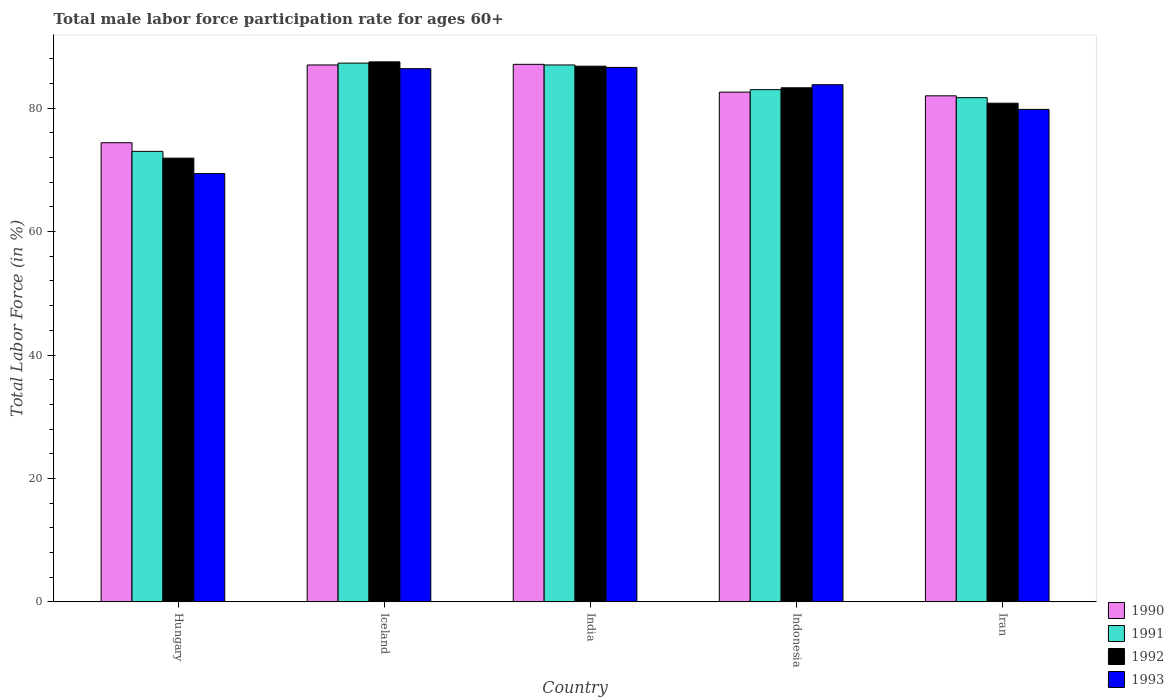How many different coloured bars are there?
Your response must be concise. 4. How many groups of bars are there?
Keep it short and to the point. 5. Are the number of bars per tick equal to the number of legend labels?
Give a very brief answer. Yes. Are the number of bars on each tick of the X-axis equal?
Offer a very short reply. Yes. How many bars are there on the 5th tick from the left?
Your response must be concise. 4. How many bars are there on the 5th tick from the right?
Keep it short and to the point. 4. What is the male labor force participation rate in 1992 in Iran?
Offer a terse response. 80.8. Across all countries, what is the maximum male labor force participation rate in 1990?
Keep it short and to the point. 87.1. Across all countries, what is the minimum male labor force participation rate in 1990?
Your answer should be compact. 74.4. In which country was the male labor force participation rate in 1991 maximum?
Give a very brief answer. Iceland. In which country was the male labor force participation rate in 1992 minimum?
Your answer should be compact. Hungary. What is the total male labor force participation rate in 1990 in the graph?
Offer a terse response. 413.1. What is the difference between the male labor force participation rate in 1992 in Hungary and that in India?
Your response must be concise. -14.9. What is the average male labor force participation rate in 1992 per country?
Offer a terse response. 82.06. In how many countries, is the male labor force participation rate in 1991 greater than 64 %?
Give a very brief answer. 5. What is the ratio of the male labor force participation rate in 1992 in Iceland to that in Iran?
Your answer should be compact. 1.08. What is the difference between the highest and the second highest male labor force participation rate in 1992?
Ensure brevity in your answer.  -3.5. What is the difference between the highest and the lowest male labor force participation rate in 1992?
Your response must be concise. 15.6. In how many countries, is the male labor force participation rate in 1990 greater than the average male labor force participation rate in 1990 taken over all countries?
Make the answer very short. 2. Is it the case that in every country, the sum of the male labor force participation rate in 1991 and male labor force participation rate in 1993 is greater than the sum of male labor force participation rate in 1990 and male labor force participation rate in 1992?
Ensure brevity in your answer.  No. What does the 1st bar from the right in Indonesia represents?
Keep it short and to the point. 1993. Is it the case that in every country, the sum of the male labor force participation rate in 1993 and male labor force participation rate in 1990 is greater than the male labor force participation rate in 1992?
Your answer should be compact. Yes. Are all the bars in the graph horizontal?
Offer a very short reply. No. How many countries are there in the graph?
Your response must be concise. 5. Are the values on the major ticks of Y-axis written in scientific E-notation?
Offer a terse response. No. Does the graph contain grids?
Give a very brief answer. No. Where does the legend appear in the graph?
Provide a succinct answer. Bottom right. How many legend labels are there?
Your response must be concise. 4. What is the title of the graph?
Give a very brief answer. Total male labor force participation rate for ages 60+. What is the label or title of the X-axis?
Offer a very short reply. Country. What is the label or title of the Y-axis?
Provide a succinct answer. Total Labor Force (in %). What is the Total Labor Force (in %) of 1990 in Hungary?
Your response must be concise. 74.4. What is the Total Labor Force (in %) of 1991 in Hungary?
Your answer should be compact. 73. What is the Total Labor Force (in %) in 1992 in Hungary?
Ensure brevity in your answer.  71.9. What is the Total Labor Force (in %) of 1993 in Hungary?
Keep it short and to the point. 69.4. What is the Total Labor Force (in %) in 1991 in Iceland?
Your response must be concise. 87.3. What is the Total Labor Force (in %) of 1992 in Iceland?
Your answer should be compact. 87.5. What is the Total Labor Force (in %) in 1993 in Iceland?
Keep it short and to the point. 86.4. What is the Total Labor Force (in %) of 1990 in India?
Keep it short and to the point. 87.1. What is the Total Labor Force (in %) of 1992 in India?
Your response must be concise. 86.8. What is the Total Labor Force (in %) of 1993 in India?
Your answer should be compact. 86.6. What is the Total Labor Force (in %) in 1990 in Indonesia?
Provide a succinct answer. 82.6. What is the Total Labor Force (in %) in 1991 in Indonesia?
Give a very brief answer. 83. What is the Total Labor Force (in %) of 1992 in Indonesia?
Your answer should be very brief. 83.3. What is the Total Labor Force (in %) of 1993 in Indonesia?
Provide a short and direct response. 83.8. What is the Total Labor Force (in %) in 1990 in Iran?
Provide a short and direct response. 82. What is the Total Labor Force (in %) in 1991 in Iran?
Offer a very short reply. 81.7. What is the Total Labor Force (in %) in 1992 in Iran?
Give a very brief answer. 80.8. What is the Total Labor Force (in %) of 1993 in Iran?
Give a very brief answer. 79.8. Across all countries, what is the maximum Total Labor Force (in %) of 1990?
Provide a short and direct response. 87.1. Across all countries, what is the maximum Total Labor Force (in %) in 1991?
Offer a very short reply. 87.3. Across all countries, what is the maximum Total Labor Force (in %) in 1992?
Keep it short and to the point. 87.5. Across all countries, what is the maximum Total Labor Force (in %) in 1993?
Offer a terse response. 86.6. Across all countries, what is the minimum Total Labor Force (in %) in 1990?
Provide a succinct answer. 74.4. Across all countries, what is the minimum Total Labor Force (in %) in 1992?
Ensure brevity in your answer.  71.9. Across all countries, what is the minimum Total Labor Force (in %) of 1993?
Ensure brevity in your answer.  69.4. What is the total Total Labor Force (in %) in 1990 in the graph?
Make the answer very short. 413.1. What is the total Total Labor Force (in %) in 1991 in the graph?
Provide a short and direct response. 412. What is the total Total Labor Force (in %) of 1992 in the graph?
Your answer should be very brief. 410.3. What is the total Total Labor Force (in %) in 1993 in the graph?
Give a very brief answer. 406. What is the difference between the Total Labor Force (in %) of 1990 in Hungary and that in Iceland?
Ensure brevity in your answer.  -12.6. What is the difference between the Total Labor Force (in %) in 1991 in Hungary and that in Iceland?
Offer a very short reply. -14.3. What is the difference between the Total Labor Force (in %) of 1992 in Hungary and that in Iceland?
Provide a succinct answer. -15.6. What is the difference between the Total Labor Force (in %) of 1993 in Hungary and that in Iceland?
Give a very brief answer. -17. What is the difference between the Total Labor Force (in %) in 1990 in Hungary and that in India?
Ensure brevity in your answer.  -12.7. What is the difference between the Total Labor Force (in %) in 1992 in Hungary and that in India?
Your response must be concise. -14.9. What is the difference between the Total Labor Force (in %) in 1993 in Hungary and that in India?
Make the answer very short. -17.2. What is the difference between the Total Labor Force (in %) of 1990 in Hungary and that in Indonesia?
Offer a terse response. -8.2. What is the difference between the Total Labor Force (in %) of 1993 in Hungary and that in Indonesia?
Provide a succinct answer. -14.4. What is the difference between the Total Labor Force (in %) in 1990 in Hungary and that in Iran?
Provide a short and direct response. -7.6. What is the difference between the Total Labor Force (in %) of 1991 in Hungary and that in Iran?
Offer a terse response. -8.7. What is the difference between the Total Labor Force (in %) in 1993 in Hungary and that in Iran?
Keep it short and to the point. -10.4. What is the difference between the Total Labor Force (in %) of 1990 in Iceland and that in India?
Your answer should be compact. -0.1. What is the difference between the Total Labor Force (in %) in 1990 in Iceland and that in Indonesia?
Ensure brevity in your answer.  4.4. What is the difference between the Total Labor Force (in %) of 1992 in Iceland and that in Indonesia?
Your answer should be very brief. 4.2. What is the difference between the Total Labor Force (in %) in 1993 in Iceland and that in Indonesia?
Give a very brief answer. 2.6. What is the difference between the Total Labor Force (in %) of 1992 in Iceland and that in Iran?
Provide a short and direct response. 6.7. What is the difference between the Total Labor Force (in %) of 1990 in India and that in Indonesia?
Offer a very short reply. 4.5. What is the difference between the Total Labor Force (in %) of 1992 in India and that in Indonesia?
Your answer should be compact. 3.5. What is the difference between the Total Labor Force (in %) of 1993 in India and that in Indonesia?
Keep it short and to the point. 2.8. What is the difference between the Total Labor Force (in %) of 1990 in India and that in Iran?
Ensure brevity in your answer.  5.1. What is the difference between the Total Labor Force (in %) of 1991 in India and that in Iran?
Your response must be concise. 5.3. What is the difference between the Total Labor Force (in %) of 1993 in India and that in Iran?
Offer a very short reply. 6.8. What is the difference between the Total Labor Force (in %) of 1991 in Indonesia and that in Iran?
Provide a succinct answer. 1.3. What is the difference between the Total Labor Force (in %) of 1992 in Indonesia and that in Iran?
Provide a succinct answer. 2.5. What is the difference between the Total Labor Force (in %) in 1993 in Indonesia and that in Iran?
Your response must be concise. 4. What is the difference between the Total Labor Force (in %) of 1990 in Hungary and the Total Labor Force (in %) of 1991 in Iceland?
Make the answer very short. -12.9. What is the difference between the Total Labor Force (in %) of 1990 in Hungary and the Total Labor Force (in %) of 1993 in Iceland?
Your answer should be very brief. -12. What is the difference between the Total Labor Force (in %) of 1991 in Hungary and the Total Labor Force (in %) of 1992 in Iceland?
Keep it short and to the point. -14.5. What is the difference between the Total Labor Force (in %) in 1991 in Hungary and the Total Labor Force (in %) in 1993 in Iceland?
Ensure brevity in your answer.  -13.4. What is the difference between the Total Labor Force (in %) of 1992 in Hungary and the Total Labor Force (in %) of 1993 in Iceland?
Give a very brief answer. -14.5. What is the difference between the Total Labor Force (in %) of 1990 in Hungary and the Total Labor Force (in %) of 1991 in India?
Keep it short and to the point. -12.6. What is the difference between the Total Labor Force (in %) of 1990 in Hungary and the Total Labor Force (in %) of 1992 in India?
Your answer should be compact. -12.4. What is the difference between the Total Labor Force (in %) in 1990 in Hungary and the Total Labor Force (in %) in 1993 in India?
Offer a terse response. -12.2. What is the difference between the Total Labor Force (in %) of 1991 in Hungary and the Total Labor Force (in %) of 1992 in India?
Provide a short and direct response. -13.8. What is the difference between the Total Labor Force (in %) in 1991 in Hungary and the Total Labor Force (in %) in 1993 in India?
Offer a terse response. -13.6. What is the difference between the Total Labor Force (in %) of 1992 in Hungary and the Total Labor Force (in %) of 1993 in India?
Provide a succinct answer. -14.7. What is the difference between the Total Labor Force (in %) in 1990 in Hungary and the Total Labor Force (in %) in 1992 in Indonesia?
Offer a terse response. -8.9. What is the difference between the Total Labor Force (in %) in 1991 in Hungary and the Total Labor Force (in %) in 1993 in Indonesia?
Your answer should be very brief. -10.8. What is the difference between the Total Labor Force (in %) in 1992 in Hungary and the Total Labor Force (in %) in 1993 in Indonesia?
Offer a terse response. -11.9. What is the difference between the Total Labor Force (in %) of 1990 in Hungary and the Total Labor Force (in %) of 1992 in Iran?
Ensure brevity in your answer.  -6.4. What is the difference between the Total Labor Force (in %) in 1992 in Hungary and the Total Labor Force (in %) in 1993 in Iran?
Ensure brevity in your answer.  -7.9. What is the difference between the Total Labor Force (in %) in 1990 in Iceland and the Total Labor Force (in %) in 1991 in India?
Keep it short and to the point. 0. What is the difference between the Total Labor Force (in %) in 1990 in Iceland and the Total Labor Force (in %) in 1992 in India?
Provide a short and direct response. 0.2. What is the difference between the Total Labor Force (in %) in 1991 in Iceland and the Total Labor Force (in %) in 1992 in India?
Your answer should be compact. 0.5. What is the difference between the Total Labor Force (in %) in 1992 in Iceland and the Total Labor Force (in %) in 1993 in India?
Ensure brevity in your answer.  0.9. What is the difference between the Total Labor Force (in %) in 1990 in Iceland and the Total Labor Force (in %) in 1992 in Indonesia?
Your answer should be compact. 3.7. What is the difference between the Total Labor Force (in %) of 1990 in Iceland and the Total Labor Force (in %) of 1993 in Indonesia?
Make the answer very short. 3.2. What is the difference between the Total Labor Force (in %) in 1990 in Iceland and the Total Labor Force (in %) in 1991 in Iran?
Provide a short and direct response. 5.3. What is the difference between the Total Labor Force (in %) in 1990 in Iceland and the Total Labor Force (in %) in 1993 in Iran?
Your answer should be compact. 7.2. What is the difference between the Total Labor Force (in %) of 1991 in Iceland and the Total Labor Force (in %) of 1992 in Iran?
Ensure brevity in your answer.  6.5. What is the difference between the Total Labor Force (in %) in 1991 in Iceland and the Total Labor Force (in %) in 1993 in Iran?
Offer a terse response. 7.5. What is the difference between the Total Labor Force (in %) in 1992 in Iceland and the Total Labor Force (in %) in 1993 in Iran?
Ensure brevity in your answer.  7.7. What is the difference between the Total Labor Force (in %) of 1990 in India and the Total Labor Force (in %) of 1991 in Indonesia?
Give a very brief answer. 4.1. What is the difference between the Total Labor Force (in %) of 1990 in India and the Total Labor Force (in %) of 1992 in Indonesia?
Offer a very short reply. 3.8. What is the difference between the Total Labor Force (in %) in 1991 in India and the Total Labor Force (in %) in 1992 in Indonesia?
Your answer should be compact. 3.7. What is the difference between the Total Labor Force (in %) of 1992 in India and the Total Labor Force (in %) of 1993 in Indonesia?
Provide a succinct answer. 3. What is the difference between the Total Labor Force (in %) in 1990 in India and the Total Labor Force (in %) in 1993 in Iran?
Provide a short and direct response. 7.3. What is the difference between the Total Labor Force (in %) in 1991 in India and the Total Labor Force (in %) in 1993 in Iran?
Offer a terse response. 7.2. What is the difference between the Total Labor Force (in %) in 1992 in India and the Total Labor Force (in %) in 1993 in Iran?
Ensure brevity in your answer.  7. What is the difference between the Total Labor Force (in %) in 1990 in Indonesia and the Total Labor Force (in %) in 1992 in Iran?
Your answer should be very brief. 1.8. What is the difference between the Total Labor Force (in %) of 1990 in Indonesia and the Total Labor Force (in %) of 1993 in Iran?
Offer a very short reply. 2.8. What is the difference between the Total Labor Force (in %) in 1991 in Indonesia and the Total Labor Force (in %) in 1992 in Iran?
Ensure brevity in your answer.  2.2. What is the difference between the Total Labor Force (in %) of 1991 in Indonesia and the Total Labor Force (in %) of 1993 in Iran?
Provide a short and direct response. 3.2. What is the average Total Labor Force (in %) in 1990 per country?
Your response must be concise. 82.62. What is the average Total Labor Force (in %) in 1991 per country?
Offer a terse response. 82.4. What is the average Total Labor Force (in %) in 1992 per country?
Offer a very short reply. 82.06. What is the average Total Labor Force (in %) in 1993 per country?
Make the answer very short. 81.2. What is the difference between the Total Labor Force (in %) in 1990 and Total Labor Force (in %) in 1991 in Hungary?
Your response must be concise. 1.4. What is the difference between the Total Labor Force (in %) in 1990 and Total Labor Force (in %) in 1992 in Hungary?
Give a very brief answer. 2.5. What is the difference between the Total Labor Force (in %) in 1991 and Total Labor Force (in %) in 1992 in Hungary?
Your answer should be very brief. 1.1. What is the difference between the Total Labor Force (in %) in 1990 and Total Labor Force (in %) in 1991 in Iceland?
Make the answer very short. -0.3. What is the difference between the Total Labor Force (in %) in 1990 and Total Labor Force (in %) in 1992 in Iceland?
Give a very brief answer. -0.5. What is the difference between the Total Labor Force (in %) of 1991 and Total Labor Force (in %) of 1992 in Iceland?
Ensure brevity in your answer.  -0.2. What is the difference between the Total Labor Force (in %) of 1990 and Total Labor Force (in %) of 1991 in India?
Keep it short and to the point. 0.1. What is the difference between the Total Labor Force (in %) in 1990 and Total Labor Force (in %) in 1992 in India?
Keep it short and to the point. 0.3. What is the difference between the Total Labor Force (in %) of 1992 and Total Labor Force (in %) of 1993 in India?
Your answer should be compact. 0.2. What is the difference between the Total Labor Force (in %) of 1992 and Total Labor Force (in %) of 1993 in Indonesia?
Your answer should be very brief. -0.5. What is the difference between the Total Labor Force (in %) of 1990 and Total Labor Force (in %) of 1993 in Iran?
Your answer should be compact. 2.2. What is the difference between the Total Labor Force (in %) in 1992 and Total Labor Force (in %) in 1993 in Iran?
Offer a very short reply. 1. What is the ratio of the Total Labor Force (in %) in 1990 in Hungary to that in Iceland?
Give a very brief answer. 0.86. What is the ratio of the Total Labor Force (in %) in 1991 in Hungary to that in Iceland?
Keep it short and to the point. 0.84. What is the ratio of the Total Labor Force (in %) of 1992 in Hungary to that in Iceland?
Offer a terse response. 0.82. What is the ratio of the Total Labor Force (in %) of 1993 in Hungary to that in Iceland?
Your answer should be very brief. 0.8. What is the ratio of the Total Labor Force (in %) in 1990 in Hungary to that in India?
Ensure brevity in your answer.  0.85. What is the ratio of the Total Labor Force (in %) in 1991 in Hungary to that in India?
Ensure brevity in your answer.  0.84. What is the ratio of the Total Labor Force (in %) in 1992 in Hungary to that in India?
Give a very brief answer. 0.83. What is the ratio of the Total Labor Force (in %) of 1993 in Hungary to that in India?
Offer a terse response. 0.8. What is the ratio of the Total Labor Force (in %) of 1990 in Hungary to that in Indonesia?
Make the answer very short. 0.9. What is the ratio of the Total Labor Force (in %) of 1991 in Hungary to that in Indonesia?
Make the answer very short. 0.88. What is the ratio of the Total Labor Force (in %) of 1992 in Hungary to that in Indonesia?
Provide a short and direct response. 0.86. What is the ratio of the Total Labor Force (in %) of 1993 in Hungary to that in Indonesia?
Ensure brevity in your answer.  0.83. What is the ratio of the Total Labor Force (in %) of 1990 in Hungary to that in Iran?
Your answer should be very brief. 0.91. What is the ratio of the Total Labor Force (in %) of 1991 in Hungary to that in Iran?
Give a very brief answer. 0.89. What is the ratio of the Total Labor Force (in %) of 1992 in Hungary to that in Iran?
Provide a short and direct response. 0.89. What is the ratio of the Total Labor Force (in %) in 1993 in Hungary to that in Iran?
Your answer should be compact. 0.87. What is the ratio of the Total Labor Force (in %) in 1990 in Iceland to that in India?
Make the answer very short. 1. What is the ratio of the Total Labor Force (in %) of 1993 in Iceland to that in India?
Offer a terse response. 1. What is the ratio of the Total Labor Force (in %) of 1990 in Iceland to that in Indonesia?
Make the answer very short. 1.05. What is the ratio of the Total Labor Force (in %) of 1991 in Iceland to that in Indonesia?
Give a very brief answer. 1.05. What is the ratio of the Total Labor Force (in %) in 1992 in Iceland to that in Indonesia?
Keep it short and to the point. 1.05. What is the ratio of the Total Labor Force (in %) of 1993 in Iceland to that in Indonesia?
Your answer should be compact. 1.03. What is the ratio of the Total Labor Force (in %) in 1990 in Iceland to that in Iran?
Your answer should be compact. 1.06. What is the ratio of the Total Labor Force (in %) of 1991 in Iceland to that in Iran?
Your response must be concise. 1.07. What is the ratio of the Total Labor Force (in %) in 1992 in Iceland to that in Iran?
Offer a very short reply. 1.08. What is the ratio of the Total Labor Force (in %) in 1993 in Iceland to that in Iran?
Provide a short and direct response. 1.08. What is the ratio of the Total Labor Force (in %) of 1990 in India to that in Indonesia?
Offer a terse response. 1.05. What is the ratio of the Total Labor Force (in %) of 1991 in India to that in Indonesia?
Your answer should be compact. 1.05. What is the ratio of the Total Labor Force (in %) in 1992 in India to that in Indonesia?
Your response must be concise. 1.04. What is the ratio of the Total Labor Force (in %) of 1993 in India to that in Indonesia?
Your response must be concise. 1.03. What is the ratio of the Total Labor Force (in %) in 1990 in India to that in Iran?
Provide a short and direct response. 1.06. What is the ratio of the Total Labor Force (in %) of 1991 in India to that in Iran?
Your answer should be compact. 1.06. What is the ratio of the Total Labor Force (in %) in 1992 in India to that in Iran?
Offer a terse response. 1.07. What is the ratio of the Total Labor Force (in %) of 1993 in India to that in Iran?
Provide a short and direct response. 1.09. What is the ratio of the Total Labor Force (in %) in 1990 in Indonesia to that in Iran?
Offer a terse response. 1.01. What is the ratio of the Total Labor Force (in %) in 1991 in Indonesia to that in Iran?
Offer a very short reply. 1.02. What is the ratio of the Total Labor Force (in %) of 1992 in Indonesia to that in Iran?
Provide a succinct answer. 1.03. What is the ratio of the Total Labor Force (in %) of 1993 in Indonesia to that in Iran?
Your response must be concise. 1.05. What is the difference between the highest and the second highest Total Labor Force (in %) of 1992?
Make the answer very short. 0.7. What is the difference between the highest and the second highest Total Labor Force (in %) of 1993?
Keep it short and to the point. 0.2. What is the difference between the highest and the lowest Total Labor Force (in %) in 1990?
Provide a short and direct response. 12.7. 